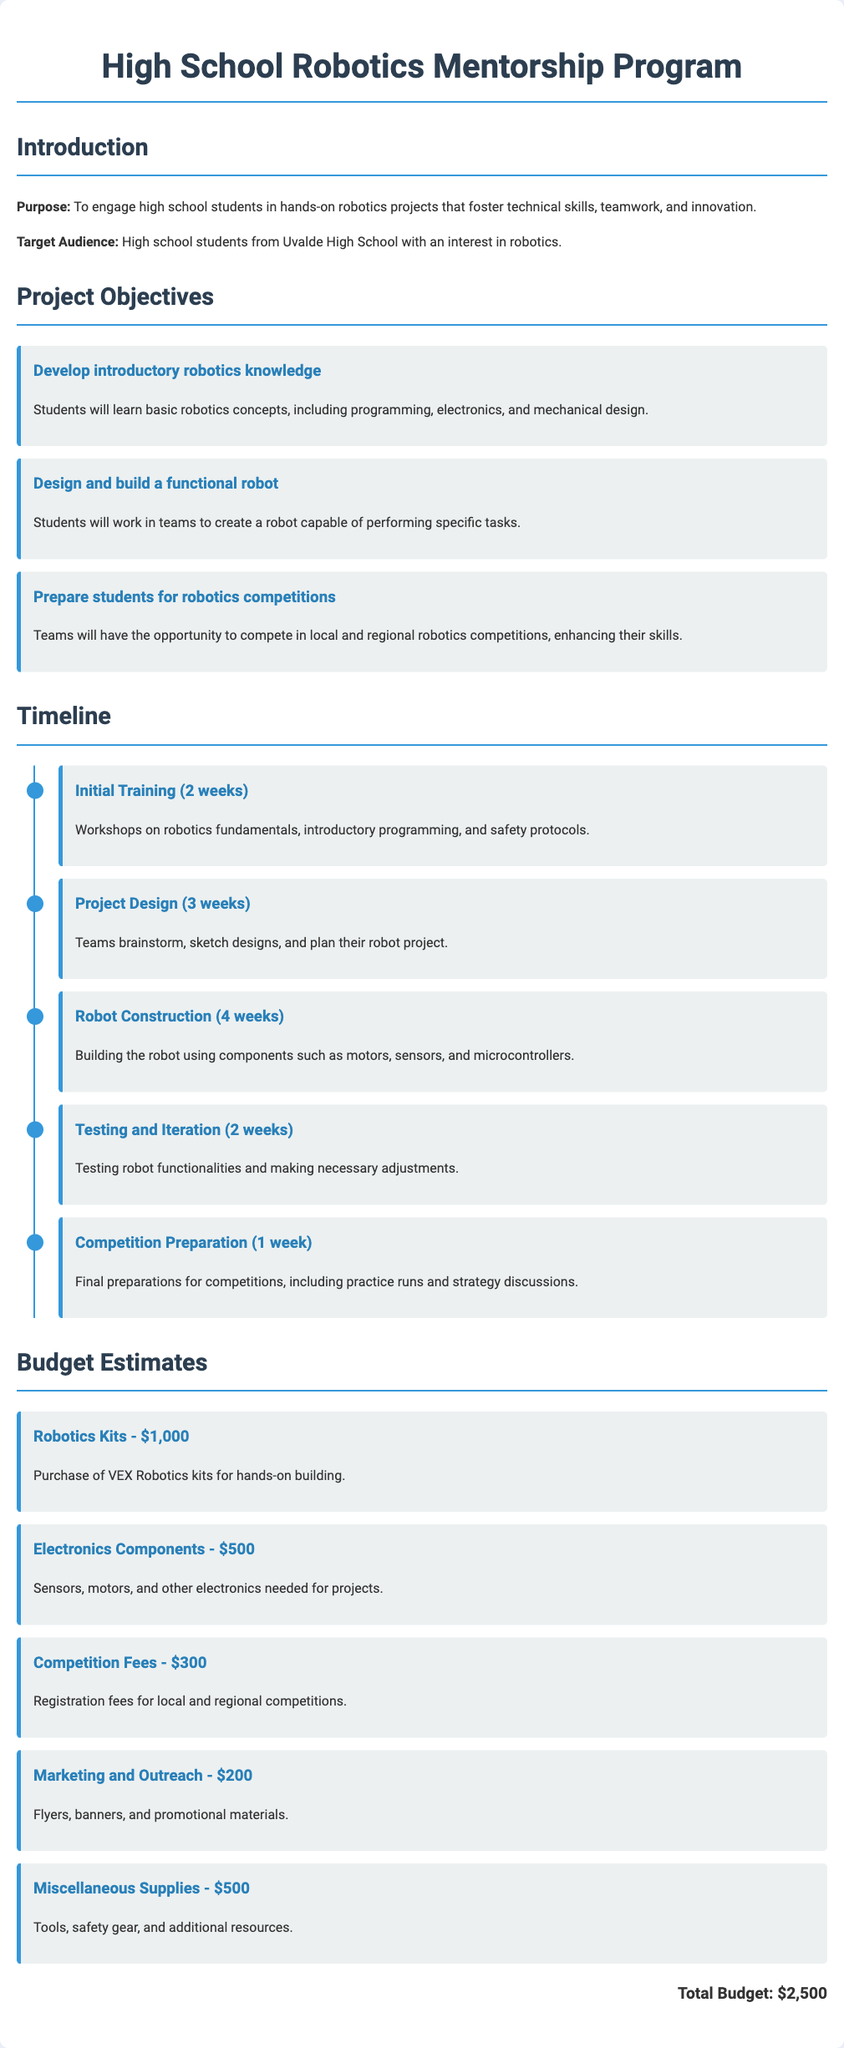what is the total budget? The total budget is listed at the end of the budget section of the document, which is $2,500.
Answer: $2,500 how many weeks is allocated for robot construction? The robot construction phase is allocated for 4 weeks, as detailed in the timeline section.
Answer: 4 weeks what is the purpose of the program? The purpose is stated in the introduction section of the document as engaging students in hands-on robotics projects.
Answer: To engage high school students in hands-on robotics projects what are the types of robotics kits mentioned? The robotics kits mentioned in the budget are VEX Robotics kits used for hands-on building.
Answer: VEX Robotics kits how many phases are in the project timeline? The project timeline outlines a total of 5 phases, as it details each developmental stage.
Answer: 5 phases which budget item has the least estimated cost? The budget item for marketing and outreach has the least estimated cost of $200, according to the budget section.
Answer: $200 what is one of the objectives of the project? One objective, stated in the objectives section, is to prepare students for robotics competitions.
Answer: Prepare students for robotics competitions how long will the initial training last? The initial training phase is specified to last for 2 weeks in the timeline section.
Answer: 2 weeks what type of students is the program targeting? The target audience for the program, as mentioned in the introduction, is high school students.
Answer: High school students 